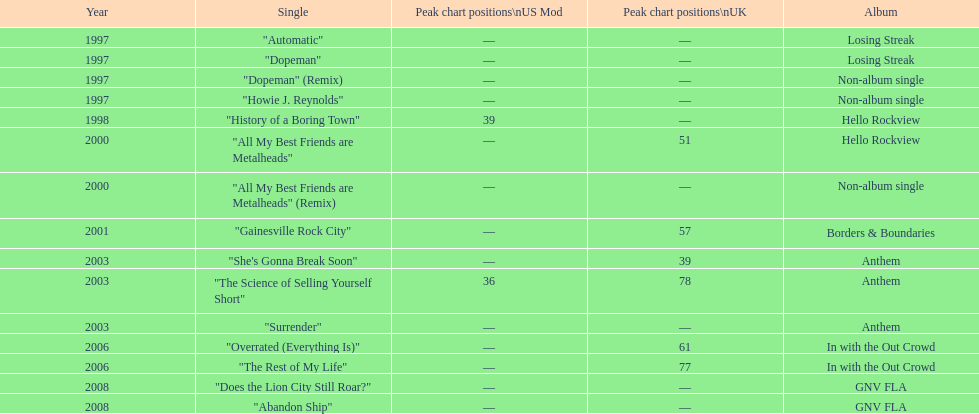In the uk, what was the typical chart placement for their singles? 60.5. 